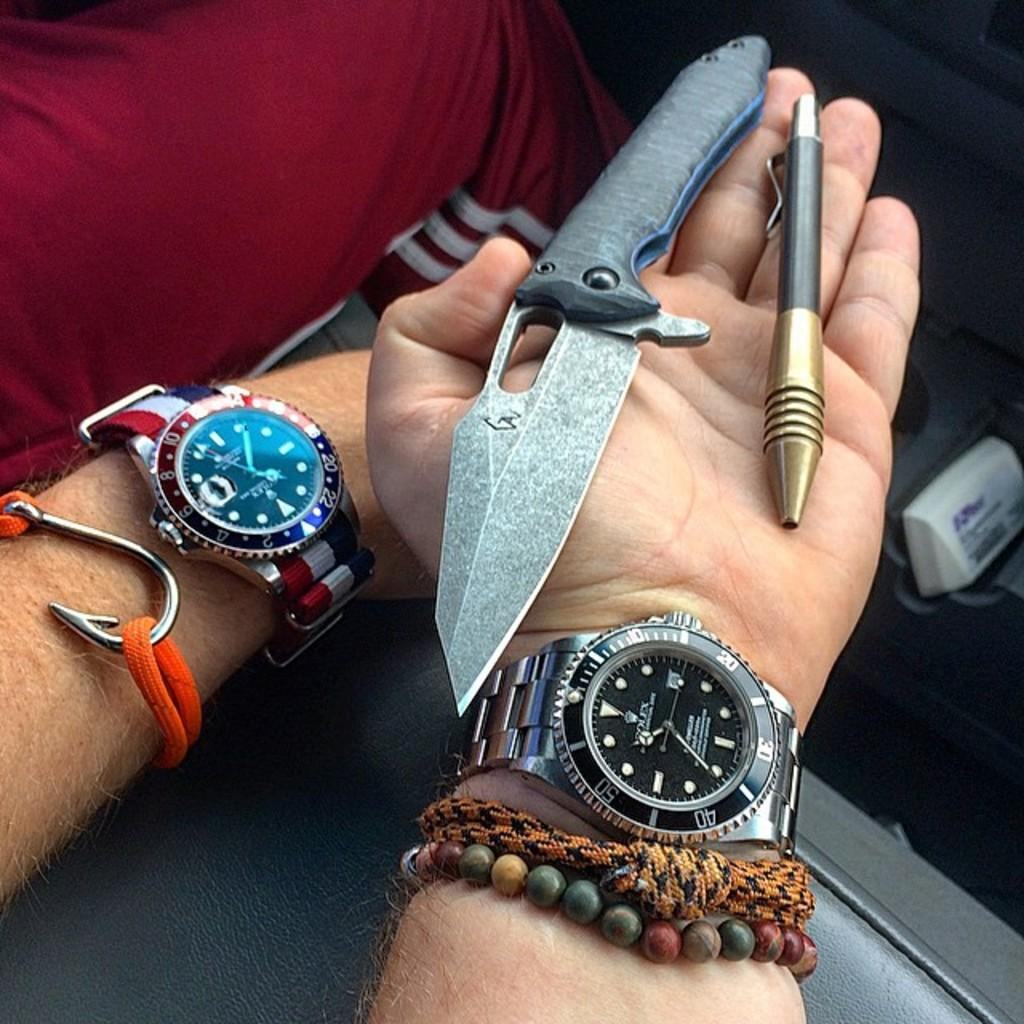<image>
Create a compact narrative representing the image presented. Person holding a knife and wearing a watch that says ROLEX on it. 